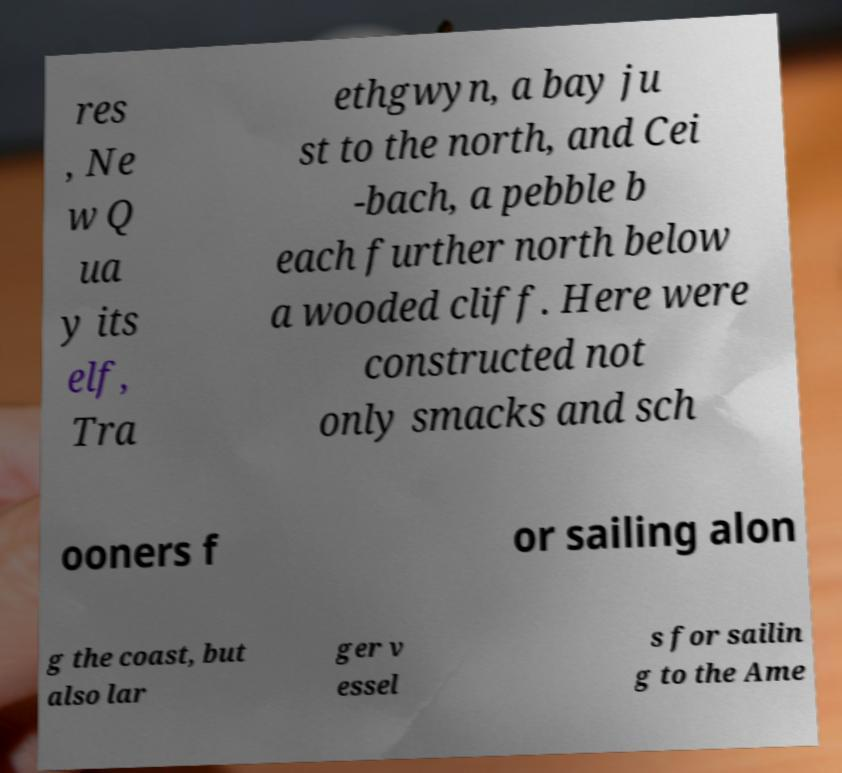Please read and relay the text visible in this image. What does it say? res , Ne w Q ua y its elf, Tra ethgwyn, a bay ju st to the north, and Cei -bach, a pebble b each further north below a wooded cliff. Here were constructed not only smacks and sch ooners f or sailing alon g the coast, but also lar ger v essel s for sailin g to the Ame 